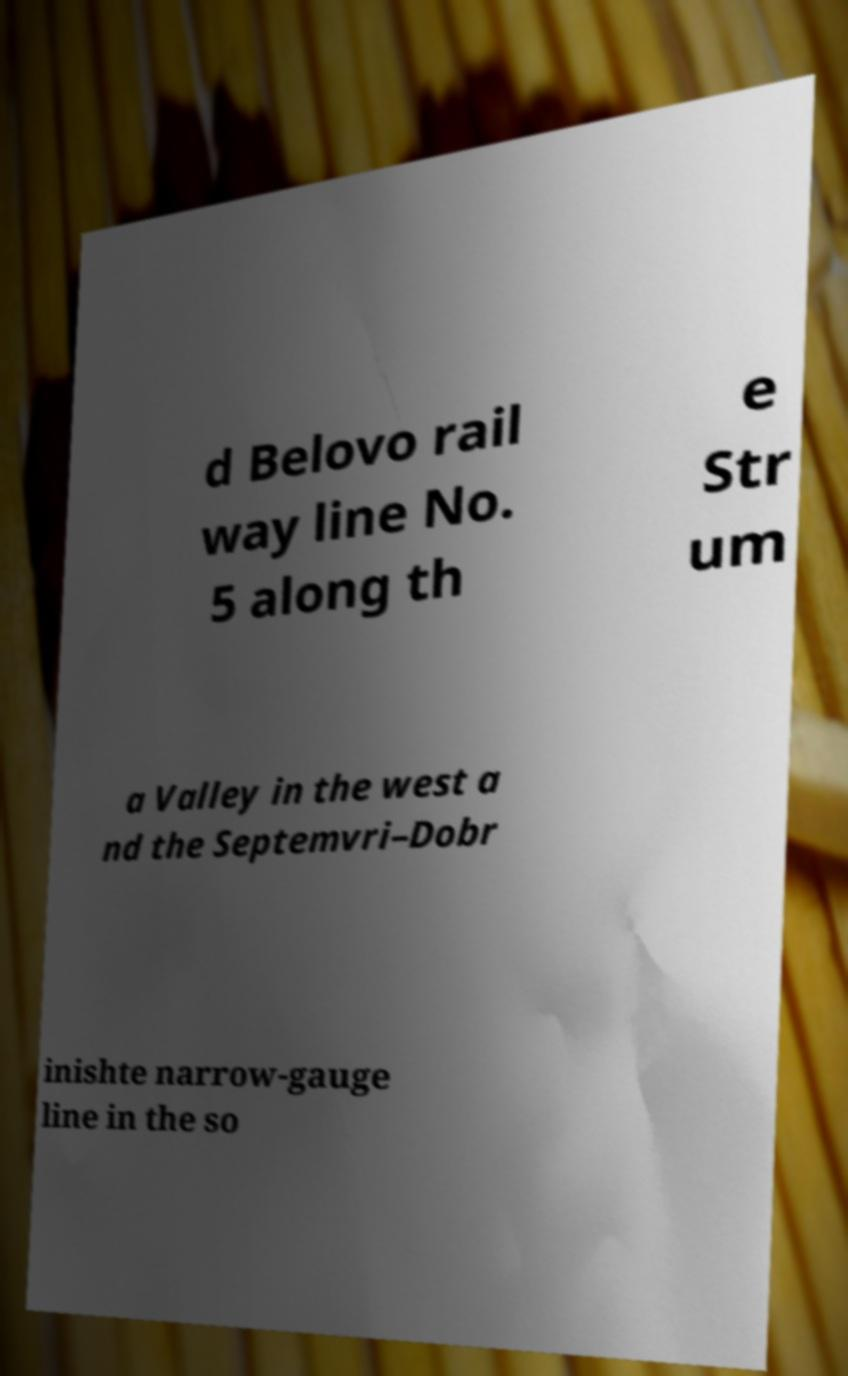There's text embedded in this image that I need extracted. Can you transcribe it verbatim? d Belovo rail way line No. 5 along th e Str um a Valley in the west a nd the Septemvri–Dobr inishte narrow-gauge line in the so 